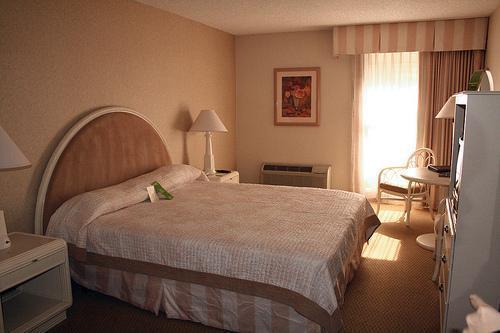How many beds are there?
Give a very brief answer. 1. 